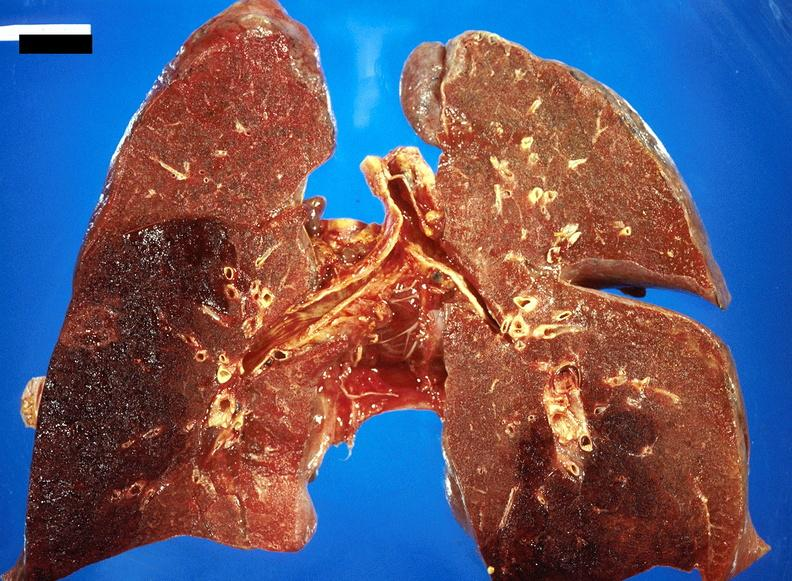does this image show subacute pulmonary thromboembolus with acute infarct?
Answer the question using a single word or phrase. Yes 